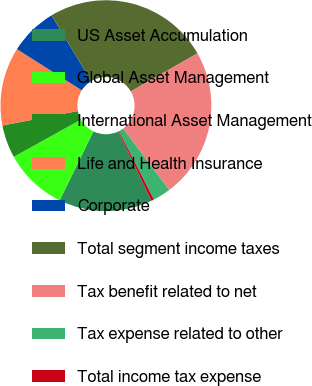<chart> <loc_0><loc_0><loc_500><loc_500><pie_chart><fcel>US Asset Accumulation<fcel>Global Asset Management<fcel>International Asset Management<fcel>Life and Health Insurance<fcel>Corporate<fcel>Total segment income taxes<fcel>Tax benefit related to net<fcel>Tax expense related to other<fcel>Total income tax expense<nl><fcel>14.34%<fcel>9.7%<fcel>5.05%<fcel>12.02%<fcel>7.37%<fcel>25.36%<fcel>23.03%<fcel>2.73%<fcel>0.4%<nl></chart> 